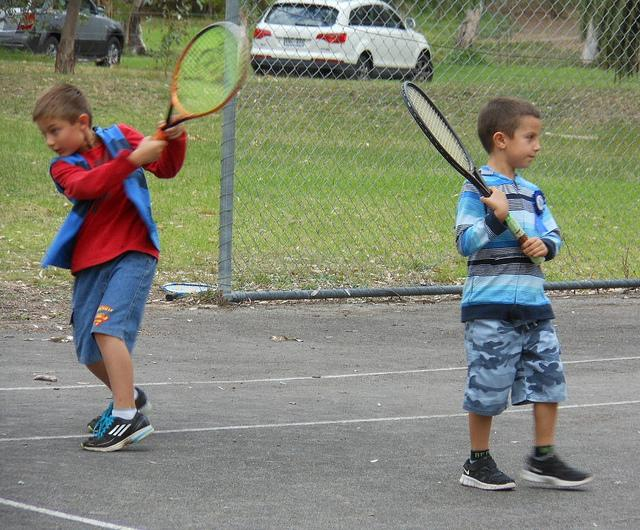What is the first name of the boy in the red's favorite hero?

Choices:
A) clark
B) tony
C) peter
D) bruce clark 